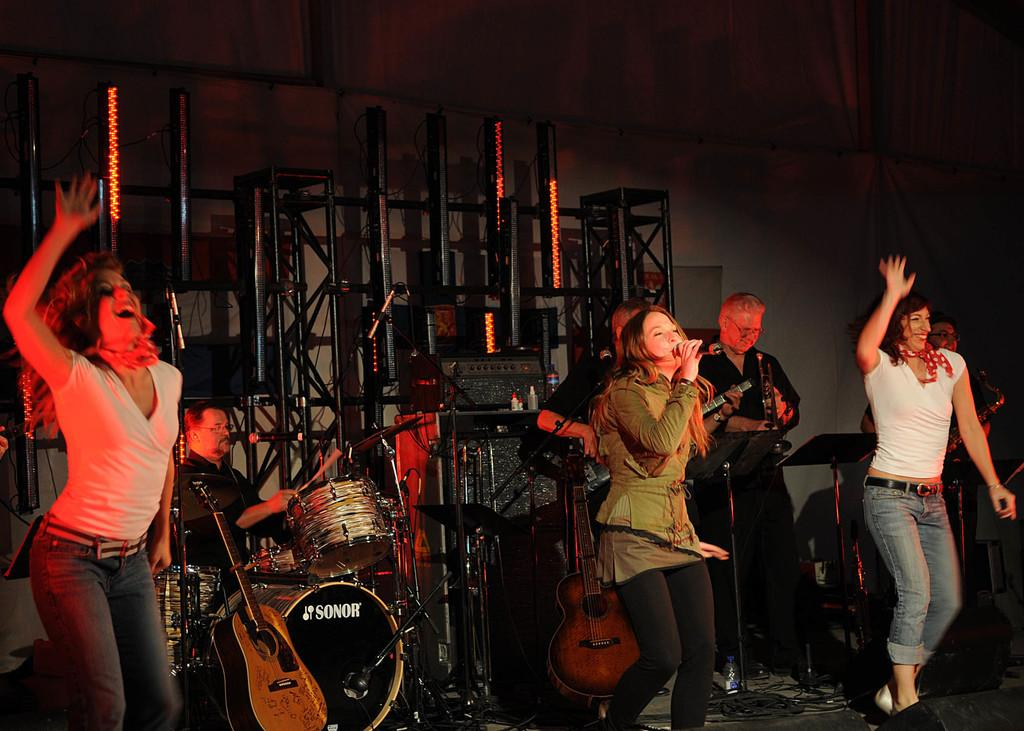What type of group is performing in the image? There is a group of a music band performing in the image. Where are they performing? They are performing on a stage. What are they doing while performing? They are singing on a microphone and playing a snare drum with drum sticks. What type of seed is being planted in the image? There is no seed being planted in the image; it features a music band performing on a stage. 